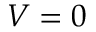<formula> <loc_0><loc_0><loc_500><loc_500>V = 0</formula> 